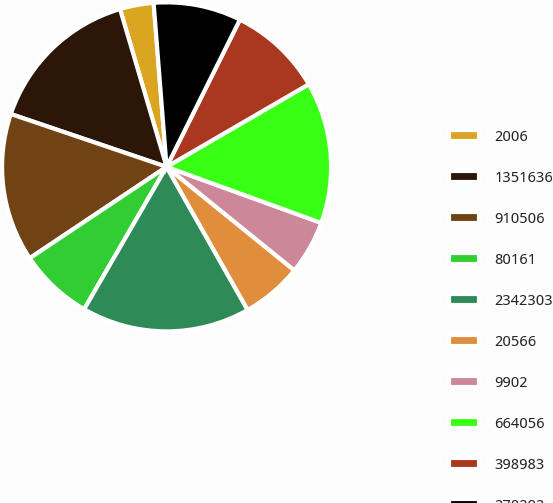Convert chart. <chart><loc_0><loc_0><loc_500><loc_500><pie_chart><fcel>2006<fcel>1351636<fcel>910506<fcel>80161<fcel>2342303<fcel>20566<fcel>9902<fcel>664056<fcel>398983<fcel>270292<nl><fcel>3.31%<fcel>15.23%<fcel>14.57%<fcel>7.28%<fcel>16.56%<fcel>5.96%<fcel>5.3%<fcel>13.91%<fcel>9.27%<fcel>8.61%<nl></chart> 